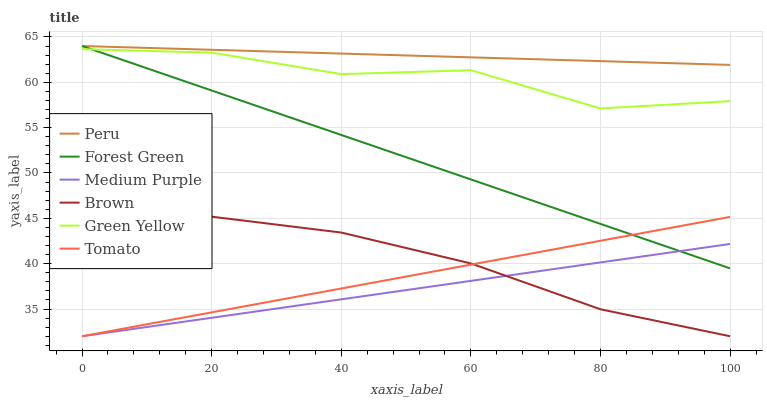Does Brown have the minimum area under the curve?
Answer yes or no. No. Does Brown have the maximum area under the curve?
Answer yes or no. No. Is Brown the smoothest?
Answer yes or no. No. Is Brown the roughest?
Answer yes or no. No. Does Forest Green have the lowest value?
Answer yes or no. No. Does Brown have the highest value?
Answer yes or no. No. Is Brown less than Forest Green?
Answer yes or no. Yes. Is Green Yellow greater than Brown?
Answer yes or no. Yes. Does Brown intersect Forest Green?
Answer yes or no. No. 